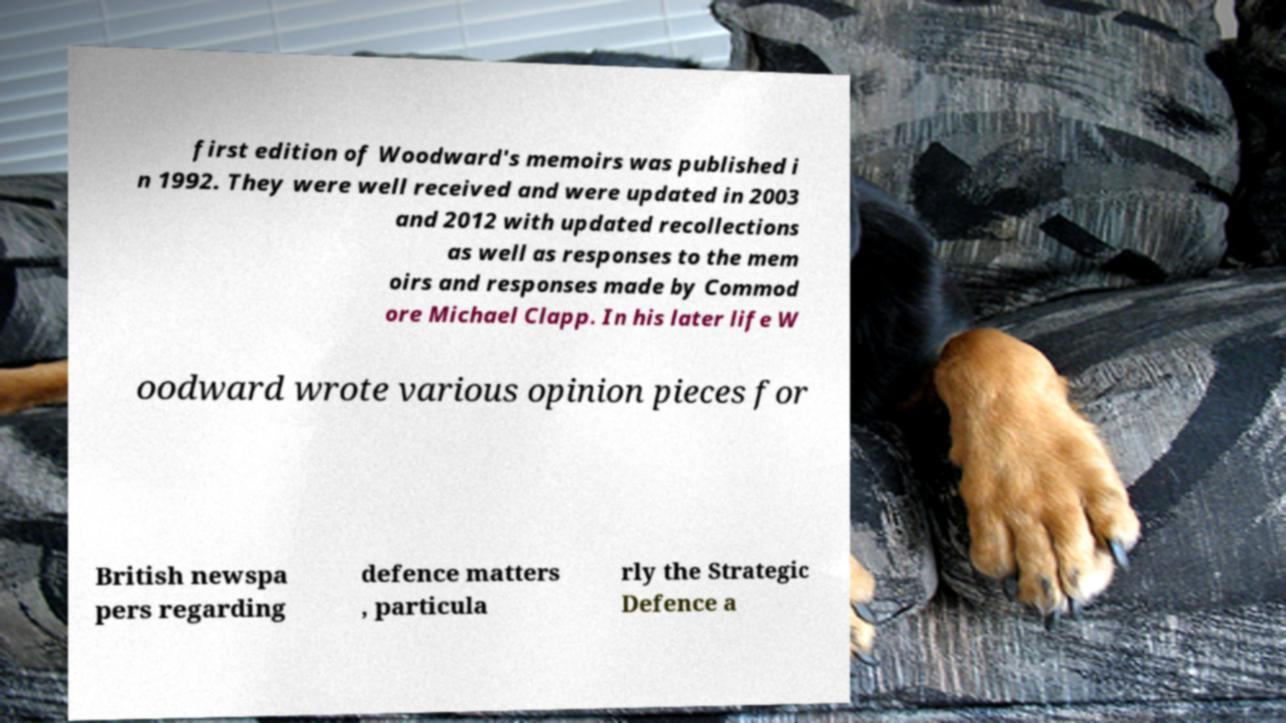Please identify and transcribe the text found in this image. first edition of Woodward's memoirs was published i n 1992. They were well received and were updated in 2003 and 2012 with updated recollections as well as responses to the mem oirs and responses made by Commod ore Michael Clapp. In his later life W oodward wrote various opinion pieces for British newspa pers regarding defence matters , particula rly the Strategic Defence a 